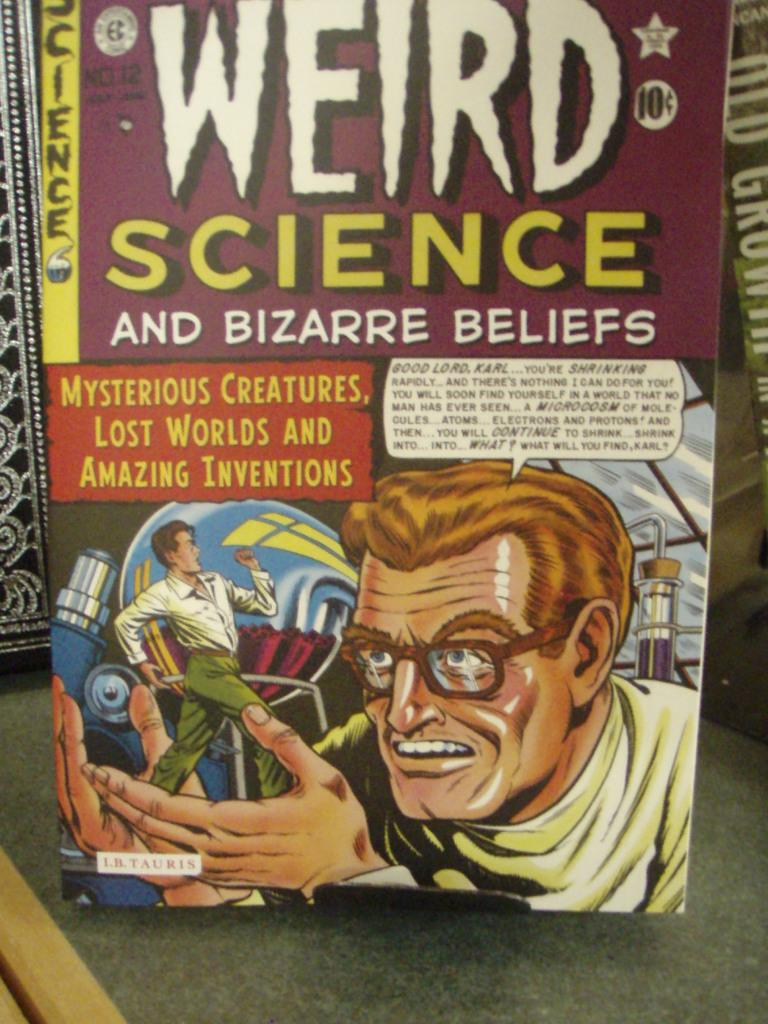<image>
Render a clear and concise summary of the photo. A comic book about weird science and amazing inventions is on the table. 